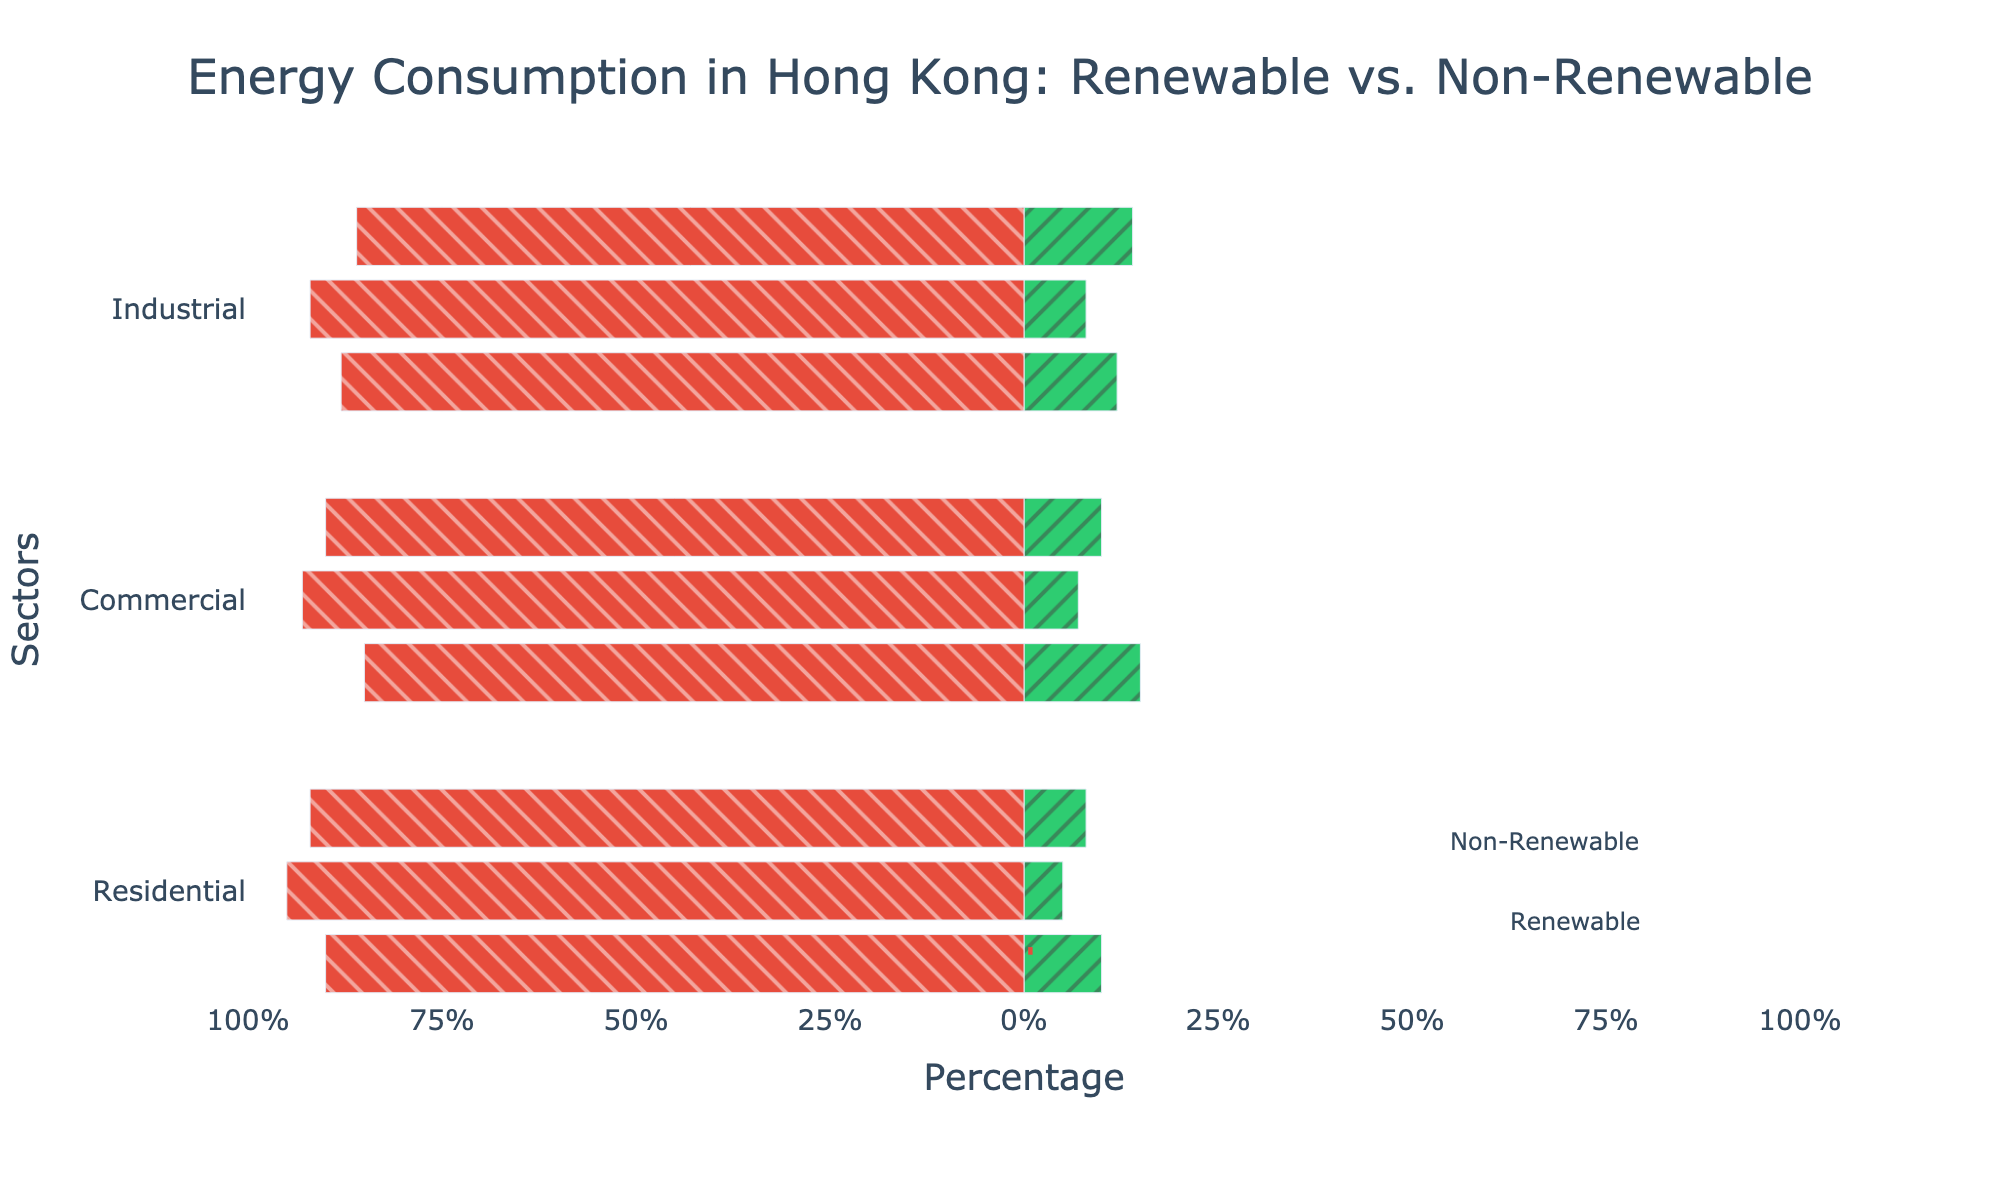Which sector has the highest proportion of renewable energy from solar? The chart shows three sectors (Residential, Commercial, Industrial) and their proportions of renewable and non-renewable energy sources. From the legend and the plot for solar energy, we can observe the green bar indicative of renewable energy. The Commercial sector has the highest proportion of renewable solar energy at 15%.
Answer: Commercial Which sector has the lowest proportion of renewable energy from wind? By observing the green segments for wind energy across the sectors, the Residential sector has the smallest proportion of renewable wind energy.
Answer: Residential What is the total proportion of renewable energy in the Residential sector? Sum the renewable energy proportions from solar, wind, and hydro in the Residential sector: 10 + 5 + 8 = 23.
Answer: 23% Which type of renewable energy is the most common across all sectors? Look at the green bars for renewable energies (solar, wind, hydro) in all sectors. Solar energy has higher values in each sector compared to wind and hydro.
Answer: Solar How does the proportion of non-renewable hydro energy in the Industrial sector compare to its renewable counterpart? The chart shows a proportion of 86% for non-renewable hydro and a proportion of 14% for renewable hydro in the Industrial sector. The non-renewable hydro proportion is significantly higher.
Answer: Non-renewable hydro is significantly higher What is the average proportion of renewable energy from hydro across all sectors? Sum the renewable hydro proportions and divide by the number of sectors: (8+10+14)/3 = 32/3 ≈ 10.67.
Answer: 10.67% Compare the proportion of renewable vs. non-renewable solar energy in the Residential sector. Renewable solar in Residential is 10%, and non-renewable (visible from negative plotting) is 90%. Non-renewable significantly outweighs renewable.
Answer: Non-renewable is higher Which sector utilizes the highest proportion of non-renewable energy from wind? Look at the red segments for wind energy across the sectors. The Residential sector has the highest proportion at 95%.
Answer: Residential What is the combined proportion of all renewable energy types in the Commercial sector? Add the renewable proportions for solar, wind, and hydro in the Commercial sector: 15 + 7 + 10 = 32.
Answer: 32% Identify the sector that has the biggest difference in renewable vs. non-renewable energy consumption for hydro. Calculate the differences for hydro in each sector:
Residential: 92 - 8 = 84,
Commercial: 90 - 10 = 80,
Industrial: 86 - 14 = 72. The Residential sector has the biggest difference.
Answer: Residential 